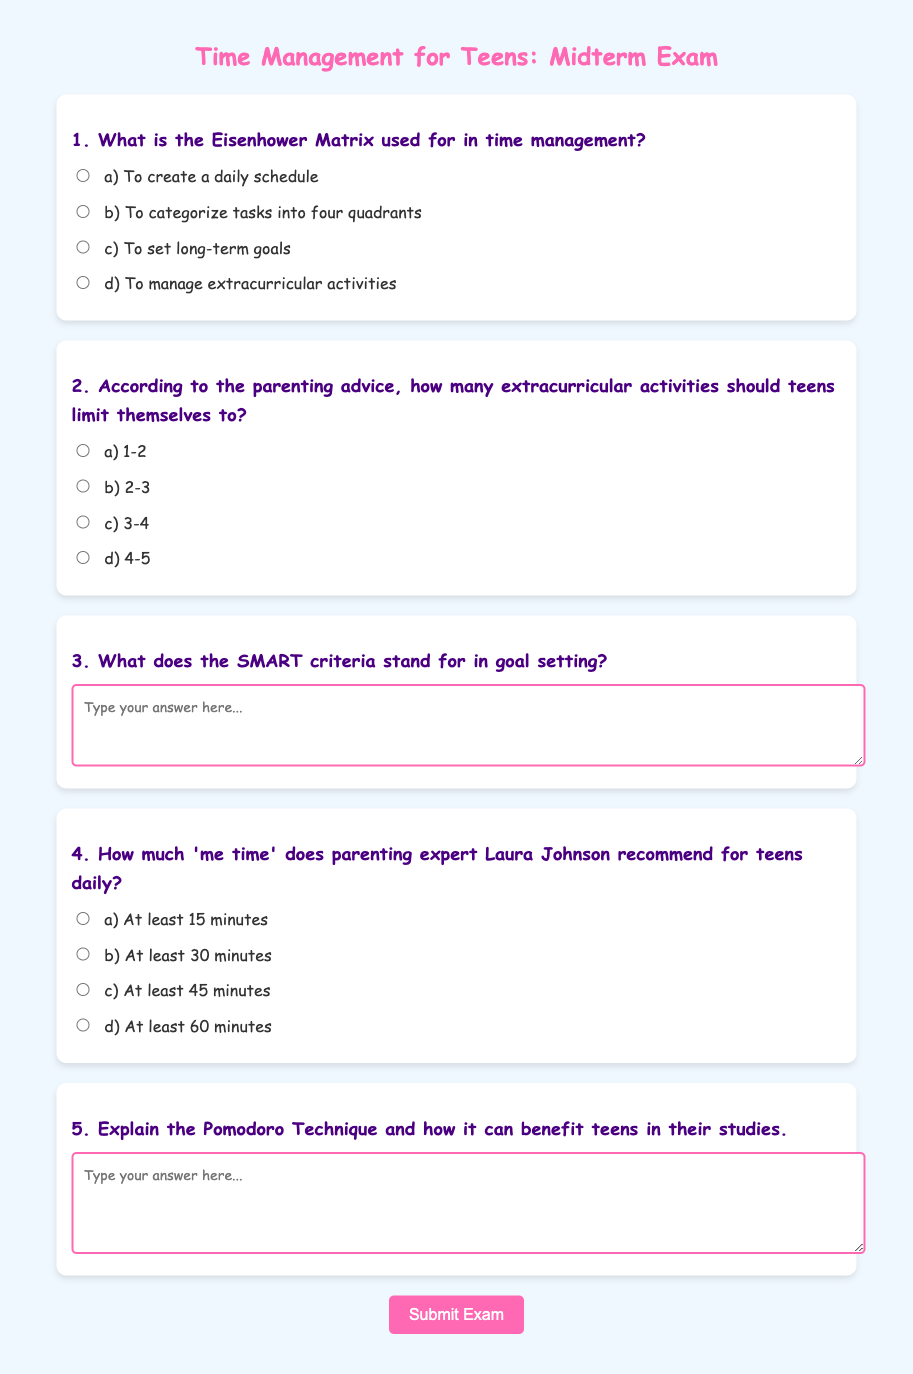What is the purpose of the Eisenhower Matrix? The Eisenhower Matrix is used to categorize tasks into four quadrants based on their urgency and importance.
Answer: Categorize tasks How many extracurricular activities should teens limit themselves to according to the parenting advice? Parenting advice suggests that teens should limit themselves to a certain number of extracurricular activities to maintain balance, which is 2-3.
Answer: 2-3 What does the 'S' in SMART criteria stand for? The 'S' in SMART criteria stands for Specific, which is one of the criteria for effective goal setting.
Answer: Specific How much 'me time' does Laura Johnson recommend for teens daily? Laura Johnson recommends at least 30 minutes of 'me time' for teens each day to support their well-being.
Answer: At least 30 minutes What is the Pomodoro Technique? The Pomodoro Technique is a time management method that involves working for 25 minutes and then taking a 5-minute break, helping teens focus and avoid burnout during studies.
Answer: Time management method What color is used for the title of the document? The title of the document is highlighted in pink color (#ff69b4) which conveys a fun and youthful tone appropriate for teens.
Answer: Pink What is the maximum width for the content displayed in the document? The document has a maximum width of 800 pixels for its content, providing a clean layout for readers.
Answer: 800 pixels 